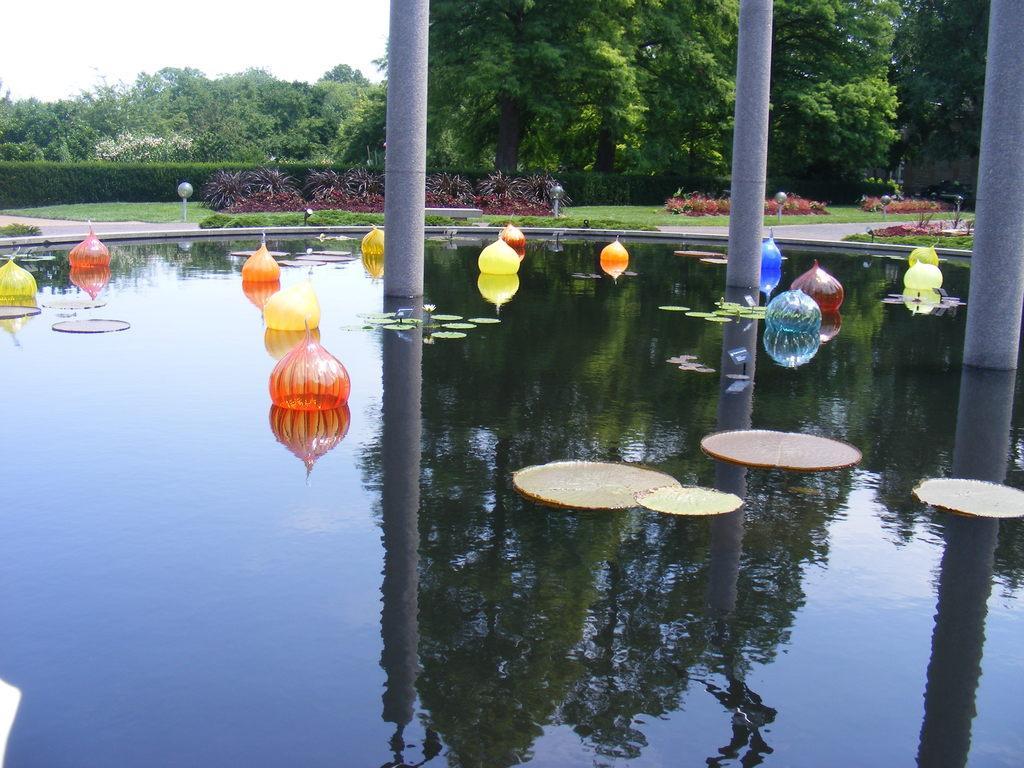Could you give a brief overview of what you see in this image? In this image we can see decoration balloons and lotus leaves are floating on the water. Here we can see the poles, shrubs, grass, light poles, trees and sky in the background. 